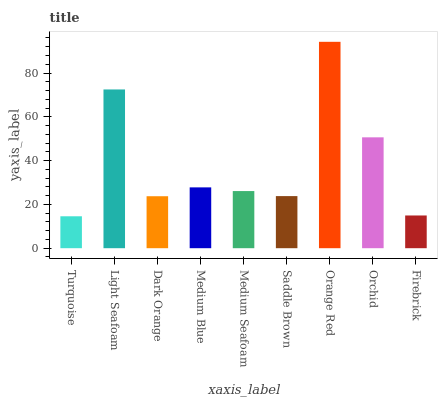Is Light Seafoam the minimum?
Answer yes or no. No. Is Light Seafoam the maximum?
Answer yes or no. No. Is Light Seafoam greater than Turquoise?
Answer yes or no. Yes. Is Turquoise less than Light Seafoam?
Answer yes or no. Yes. Is Turquoise greater than Light Seafoam?
Answer yes or no. No. Is Light Seafoam less than Turquoise?
Answer yes or no. No. Is Medium Seafoam the high median?
Answer yes or no. Yes. Is Medium Seafoam the low median?
Answer yes or no. Yes. Is Orchid the high median?
Answer yes or no. No. Is Dark Orange the low median?
Answer yes or no. No. 